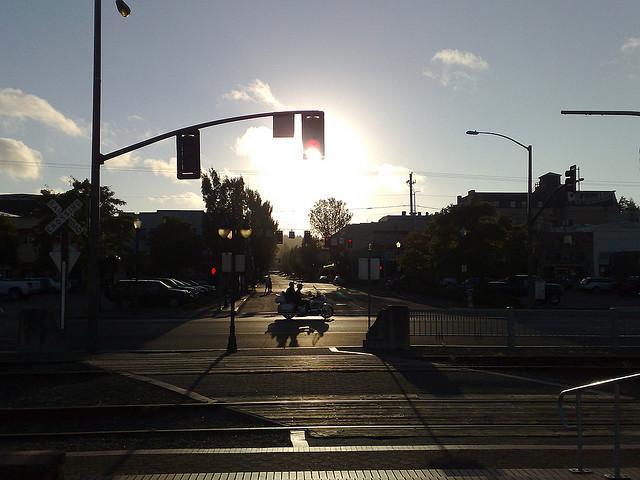How many boats are moving in the photo?
Give a very brief answer. 0. 